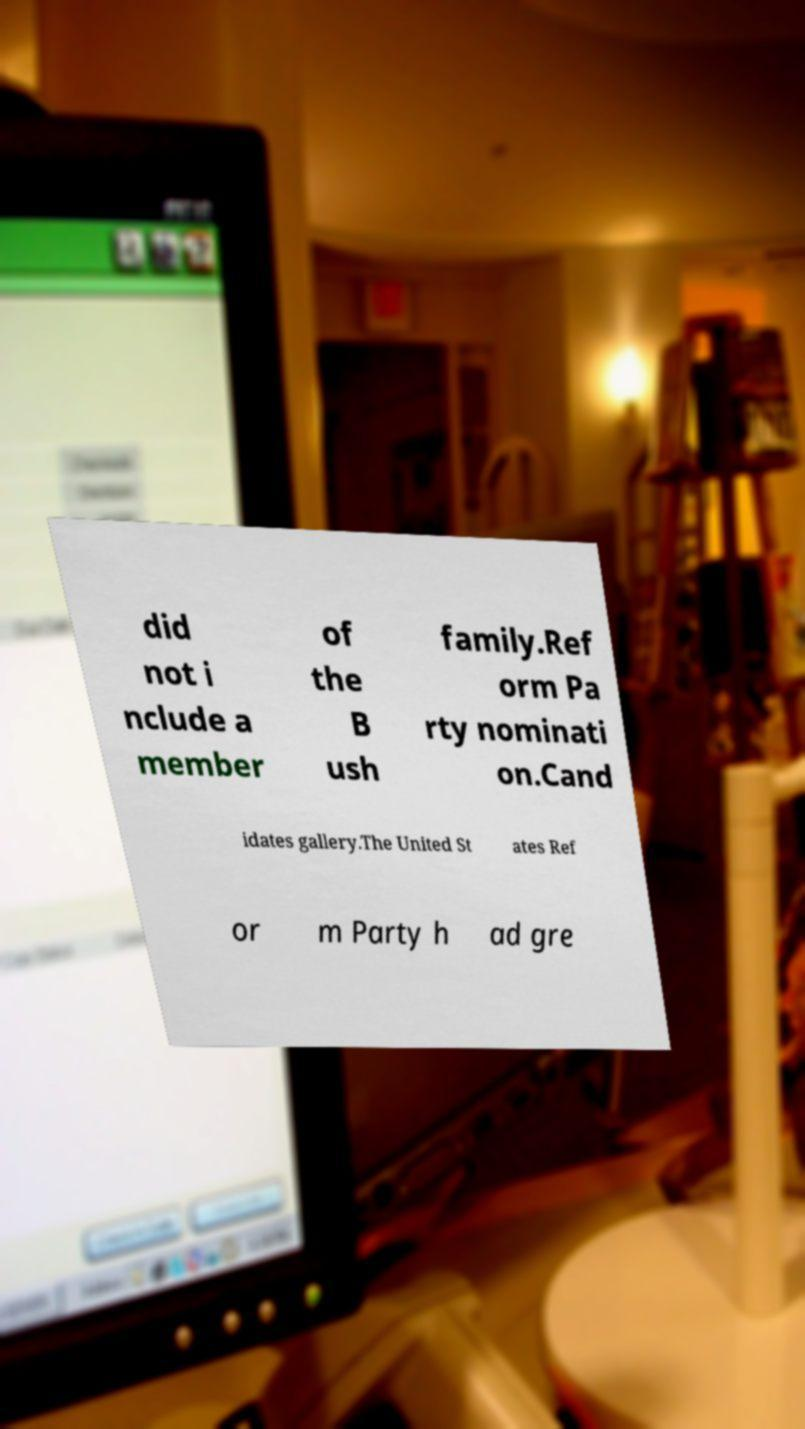What messages or text are displayed in this image? I need them in a readable, typed format. did not i nclude a member of the B ush family.Ref orm Pa rty nominati on.Cand idates gallery.The United St ates Ref or m Party h ad gre 